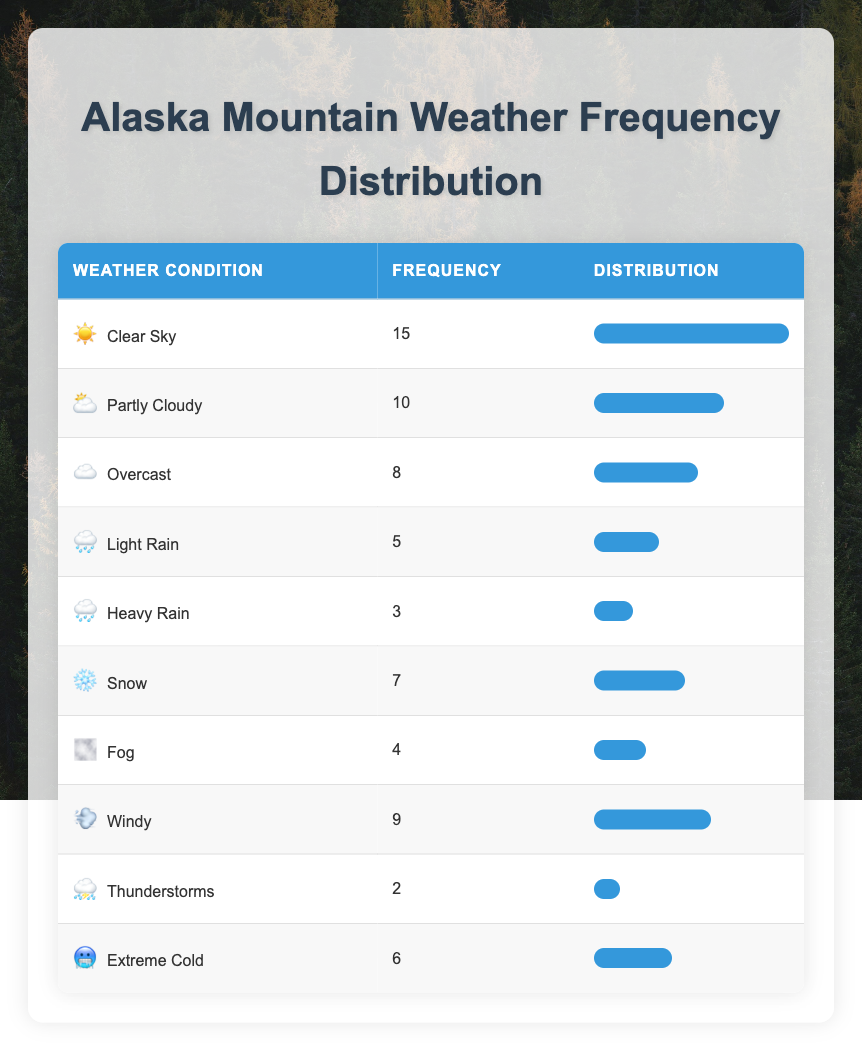What is the most frequently recorded weather condition? The table shows weather conditions along with their frequencies. The condition with the highest frequency is "Clear Sky," which appears 15 times.
Answer: Clear Sky How many weather conditions have a frequency of 5 or higher? We examine the frequency column for conditions that have a value of 5 or more. The conditions are "Clear Sky" (15), "Partly Cloudy" (10), "Windy" (9), "Snow" (7), and "Extreme Cold" (6). That's a total of 5 conditions.
Answer: 5 What is the frequency of heavy rain? Looking at the table, the frequency for "Heavy Rain" is listed as 3, which indicates it was recorded 3 times.
Answer: 3 Which weather condition has the lowest frequency? The table shows that "Thunderstorms" has the lowest frequency, recorded 2 times.
Answer: Thunderstorms What is the average frequency of all recorded weather conditions? To calculate the average, we sum the frequencies: 15 + 10 + 8 + 5 + 3 + 7 + 4 + 9 + 2 + 6 = 69. Since there are 10 conditions, we divide the total (69) by the number of conditions (10) to get an average of 6.9.
Answer: 6.9 Is "Fog" recorded more frequently than "Light Rain"? We compare the frequencies of "Fog," which is 4, and "Light Rain," which is 5. Since 4 is less than 5, the statement is false.
Answer: No How many conditions are more frequent than "Snow"? "Snow" has a frequency of 7. We can identify conditions more frequent by checking the frequency list. "Clear Sky" (15), "Partly Cloudy" (10), and "Windy" (9) are all greater than 7. Thus, there are 3 conditions that meet this criterion.
Answer: 3 Is the combined frequency of rainy conditions (Light Rain + Heavy Rain) greater than that of snowy conditions? We first find the frequencies: "Light Rain" is 5 and "Heavy Rain" is 3, summing them gives us 8. The frequency of "Snow" is 7. Comparing 8 and 7 shows that 8 is greater than 7, making the statement true.
Answer: Yes 